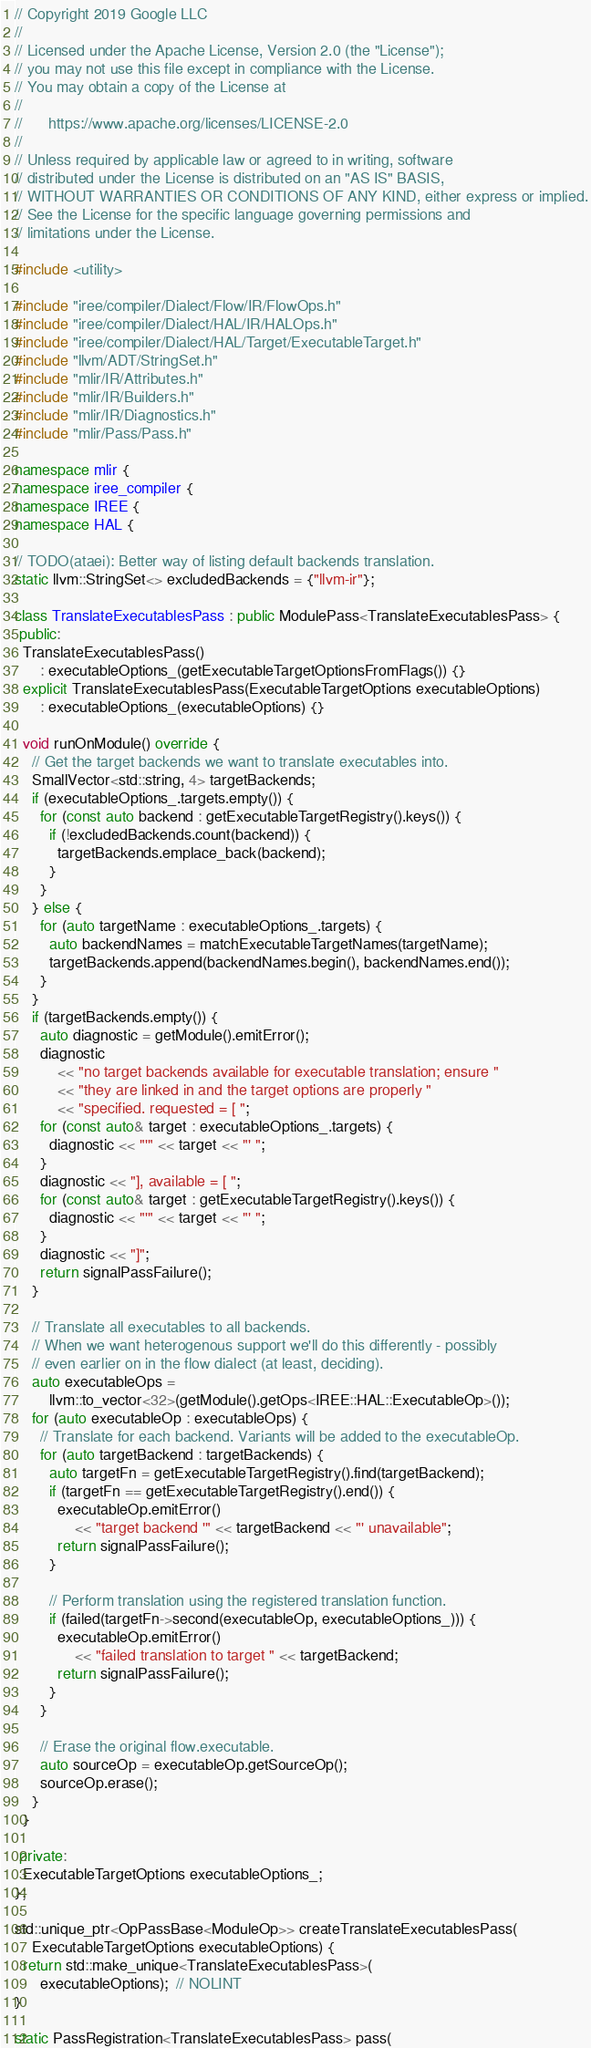Convert code to text. <code><loc_0><loc_0><loc_500><loc_500><_C++_>// Copyright 2019 Google LLC
//
// Licensed under the Apache License, Version 2.0 (the "License");
// you may not use this file except in compliance with the License.
// You may obtain a copy of the License at
//
//      https://www.apache.org/licenses/LICENSE-2.0
//
// Unless required by applicable law or agreed to in writing, software
// distributed under the License is distributed on an "AS IS" BASIS,
// WITHOUT WARRANTIES OR CONDITIONS OF ANY KIND, either express or implied.
// See the License for the specific language governing permissions and
// limitations under the License.

#include <utility>

#include "iree/compiler/Dialect/Flow/IR/FlowOps.h"
#include "iree/compiler/Dialect/HAL/IR/HALOps.h"
#include "iree/compiler/Dialect/HAL/Target/ExecutableTarget.h"
#include "llvm/ADT/StringSet.h"
#include "mlir/IR/Attributes.h"
#include "mlir/IR/Builders.h"
#include "mlir/IR/Diagnostics.h"
#include "mlir/Pass/Pass.h"

namespace mlir {
namespace iree_compiler {
namespace IREE {
namespace HAL {

// TODO(ataei): Better way of listing default backends translation.
static llvm::StringSet<> excludedBackends = {"llvm-ir"};

class TranslateExecutablesPass : public ModulePass<TranslateExecutablesPass> {
 public:
  TranslateExecutablesPass()
      : executableOptions_(getExecutableTargetOptionsFromFlags()) {}
  explicit TranslateExecutablesPass(ExecutableTargetOptions executableOptions)
      : executableOptions_(executableOptions) {}

  void runOnModule() override {
    // Get the target backends we want to translate executables into.
    SmallVector<std::string, 4> targetBackends;
    if (executableOptions_.targets.empty()) {
      for (const auto backend : getExecutableTargetRegistry().keys()) {
        if (!excludedBackends.count(backend)) {
          targetBackends.emplace_back(backend);
        }
      }
    } else {
      for (auto targetName : executableOptions_.targets) {
        auto backendNames = matchExecutableTargetNames(targetName);
        targetBackends.append(backendNames.begin(), backendNames.end());
      }
    }
    if (targetBackends.empty()) {
      auto diagnostic = getModule().emitError();
      diagnostic
          << "no target backends available for executable translation; ensure "
          << "they are linked in and the target options are properly "
          << "specified. requested = [ ";
      for (const auto& target : executableOptions_.targets) {
        diagnostic << "'" << target << "' ";
      }
      diagnostic << "], available = [ ";
      for (const auto& target : getExecutableTargetRegistry().keys()) {
        diagnostic << "'" << target << "' ";
      }
      diagnostic << "]";
      return signalPassFailure();
    }

    // Translate all executables to all backends.
    // When we want heterogenous support we'll do this differently - possibly
    // even earlier on in the flow dialect (at least, deciding).
    auto executableOps =
        llvm::to_vector<32>(getModule().getOps<IREE::HAL::ExecutableOp>());
    for (auto executableOp : executableOps) {
      // Translate for each backend. Variants will be added to the executableOp.
      for (auto targetBackend : targetBackends) {
        auto targetFn = getExecutableTargetRegistry().find(targetBackend);
        if (targetFn == getExecutableTargetRegistry().end()) {
          executableOp.emitError()
              << "target backend '" << targetBackend << "' unavailable";
          return signalPassFailure();
        }

        // Perform translation using the registered translation function.
        if (failed(targetFn->second(executableOp, executableOptions_))) {
          executableOp.emitError()
              << "failed translation to target " << targetBackend;
          return signalPassFailure();
        }
      }

      // Erase the original flow.executable.
      auto sourceOp = executableOp.getSourceOp();
      sourceOp.erase();
    }
  }

 private:
  ExecutableTargetOptions executableOptions_;
};

std::unique_ptr<OpPassBase<ModuleOp>> createTranslateExecutablesPass(
    ExecutableTargetOptions executableOptions) {
  return std::make_unique<TranslateExecutablesPass>(
      executableOptions);  // NOLINT
}

static PassRegistration<TranslateExecutablesPass> pass(</code> 